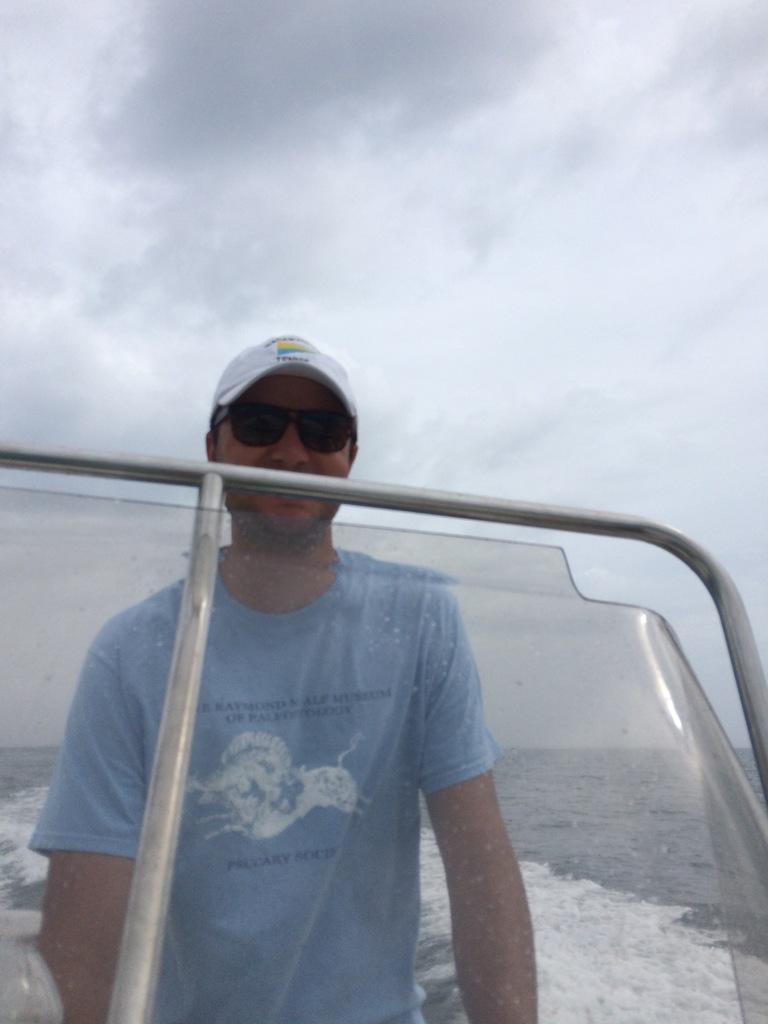Describe this image in one or two sentences. This image consists of a man wearing a blue T-shirt. He is standing in the boat. In the background, there is water. It looks like it is clicked in an ocean. At the top, there are clouds in the sky. 